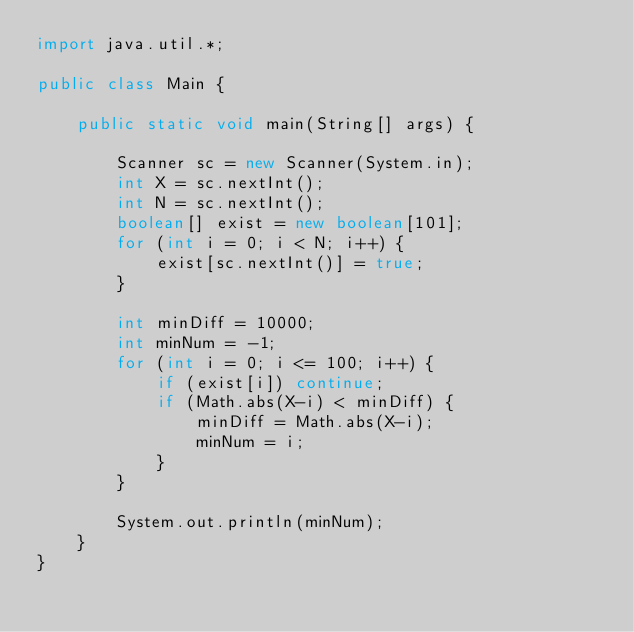<code> <loc_0><loc_0><loc_500><loc_500><_Java_>import java.util.*;

public class Main {

    public static void main(String[] args) {

        Scanner sc = new Scanner(System.in);
        int X = sc.nextInt();
        int N = sc.nextInt();
        boolean[] exist = new boolean[101];
        for (int i = 0; i < N; i++) {
            exist[sc.nextInt()] = true;
        }

        int minDiff = 10000;
        int minNum = -1;
        for (int i = 0; i <= 100; i++) {
            if (exist[i]) continue;
            if (Math.abs(X-i) < minDiff) {
                minDiff = Math.abs(X-i);
                minNum = i;
            }
        }

        System.out.println(minNum);
    }
}
</code> 